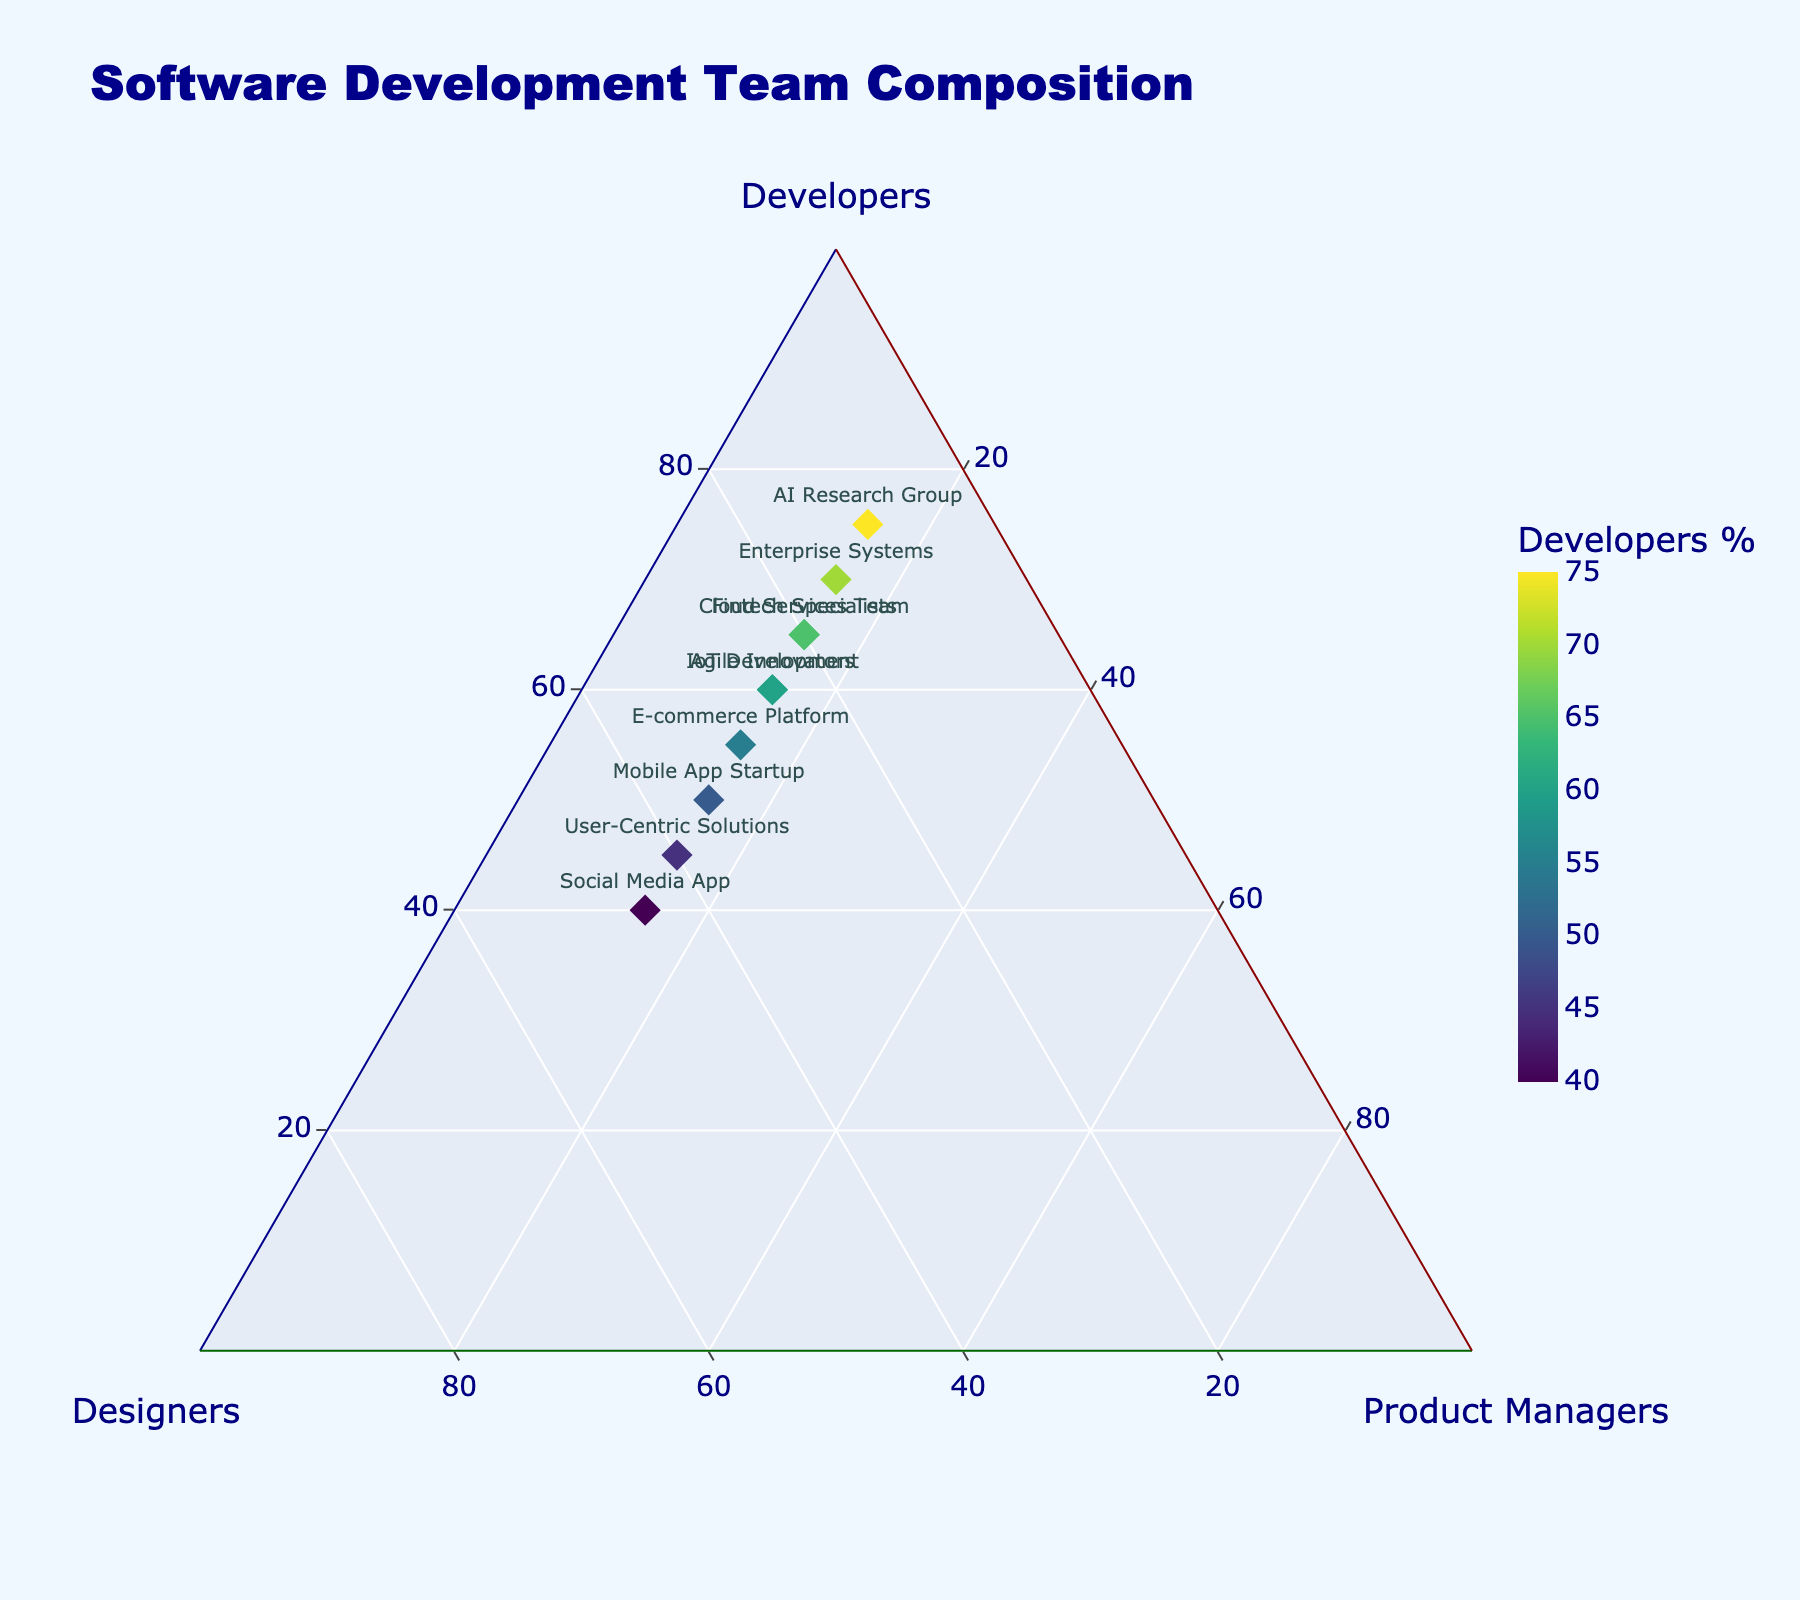What's the title of the plot? The title of the plot is displayed at the top of the figure and typically summarizes its content.
Answer: Software Development Team Composition How many teams are shown in the plot? By counting the number of unique team names or data points marked on the plot, you can determine the number of teams. There are 10 distinct data points representing different teams.
Answer: 10 Which team has the highest percentage of developers? By looking at the points on the plot, you can identify the team positioned closest to the Developer axis. The AI Research Group is this team.
Answer: AI Research Group Which team has a higher percentage of designers, Mobile App Startup or User-Centric Solutions? Compare the positions of Mobile App Startup and User-Centric Solutions relative to the Designers axis. User-Centric Solutions is positioned closer to the Designer axis, indicating a higher percentage of designers.
Answer: User-Centric Solutions Are there any teams with an equal percentage of product managers? The percentages for Product Managers are displayed along the Product Managers axis. Observing this axis reveals that all teams have exactly 15% Product Managers.
Answer: Yes Which team is closest to having an equal percentage of developers, designers, and product managers? To determine this, find a point nearest to the center of the ternary plot, where each axis would potentially have an equal share. No team has exactly equal portions, but closer inspection shows Social Media App has the most balanced distribution though it is not equal.
Answer: Social Media App What's the range of percentages for developers across the teams shown? Inspect the Developer axis to find the minimum and maximum percentages of developers. The lowest is 40% (Social Media App) and the highest is 75% (AI Research Group).
Answer: 40% to 75% Which teams have exactly 20% designers? Looking at the Designers axis, identify the points that align with the 20% mark. Cloud Services Team and Fintech Specialists have exactly 20% designers.
Answer: Cloud Services Team, Fintech Specialists What is the average percentage of designers across all teams? To calculate this, sum the percentages of designers for all teams (25 + 40 + 15 + 35 + 20 + 10 + 30 + 45 + 25 + 20 = 265) and divide by the number of teams (10). The average designers percentage is 265/10 = 26.5%.
Answer: 26.5% Which team has the lowest percentage of designers? Examine the points along the Designers axis to identify the team closest to the minimum value. The AI Research Group is the team with the lowest percentage of designers, which is 10%.
Answer: AI Research Group 